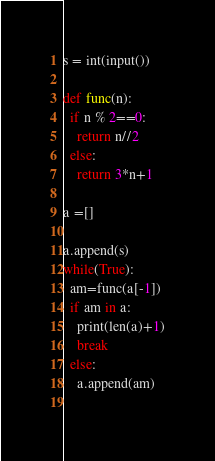Convert code to text. <code><loc_0><loc_0><loc_500><loc_500><_Python_>s = int(input())

def func(n):
  if n % 2==0:
    return n//2
  else:
    return 3*n+1

a =[]

a.append(s)
while(True):
  am=func(a[-1])
  if am in a:
    print(len(a)+1)
    break
  else:
    a.append(am)
  </code> 